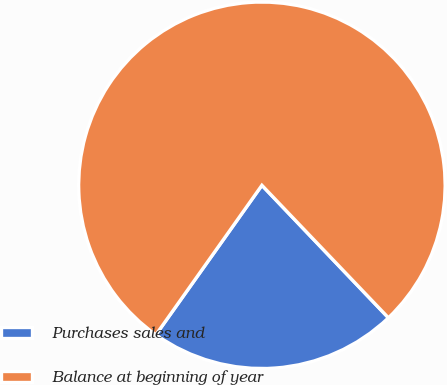Convert chart to OTSL. <chart><loc_0><loc_0><loc_500><loc_500><pie_chart><fcel>Purchases sales and<fcel>Balance at beginning of year<nl><fcel>21.95%<fcel>78.05%<nl></chart> 